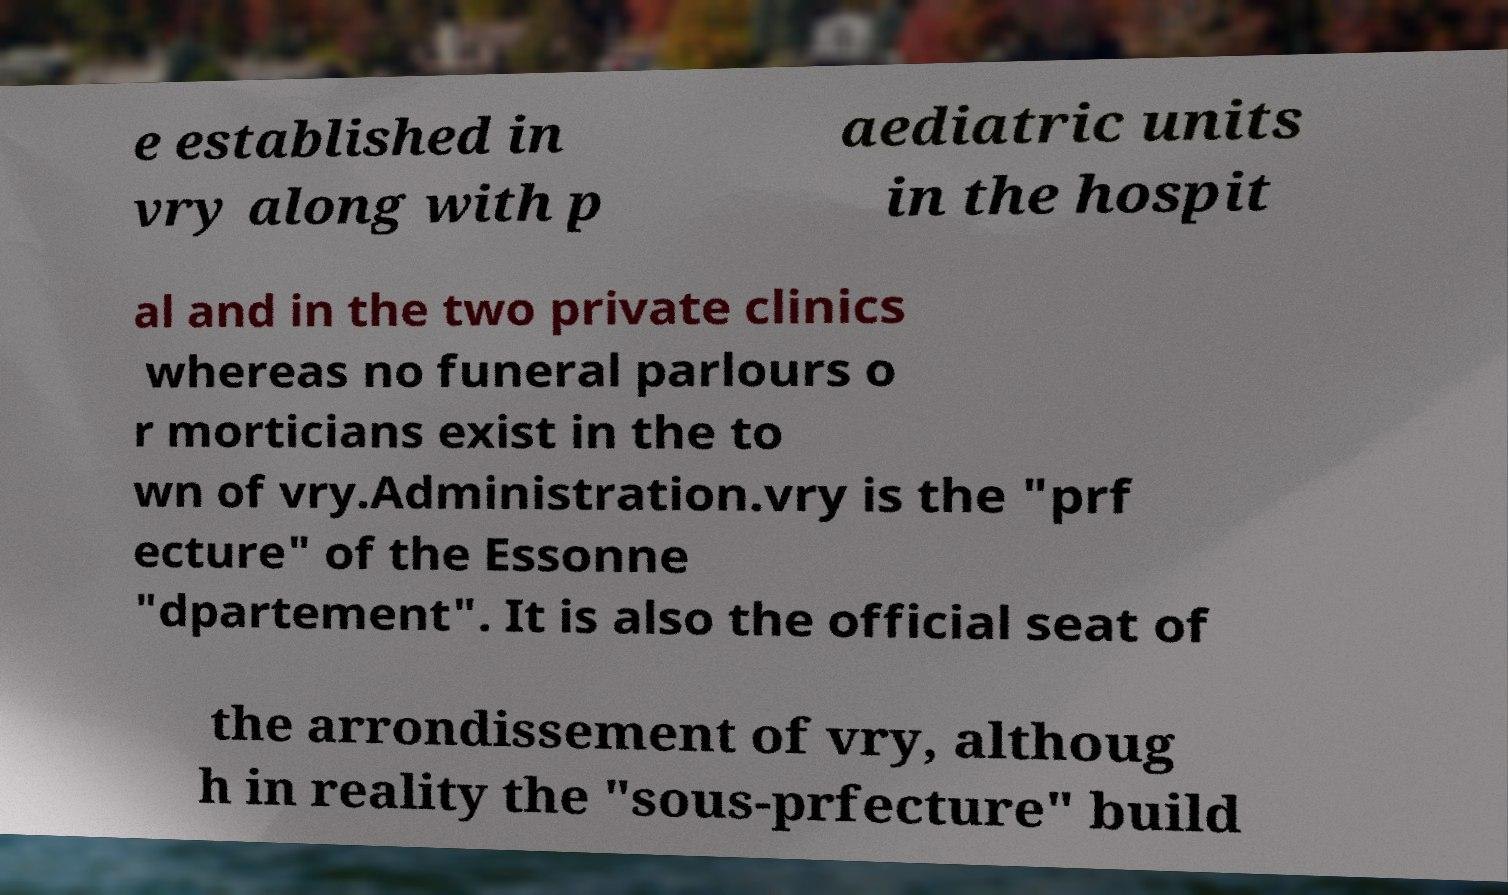Could you assist in decoding the text presented in this image and type it out clearly? e established in vry along with p aediatric units in the hospit al and in the two private clinics whereas no funeral parlours o r morticians exist in the to wn of vry.Administration.vry is the "prf ecture" of the Essonne "dpartement". It is also the official seat of the arrondissement of vry, althoug h in reality the "sous-prfecture" build 